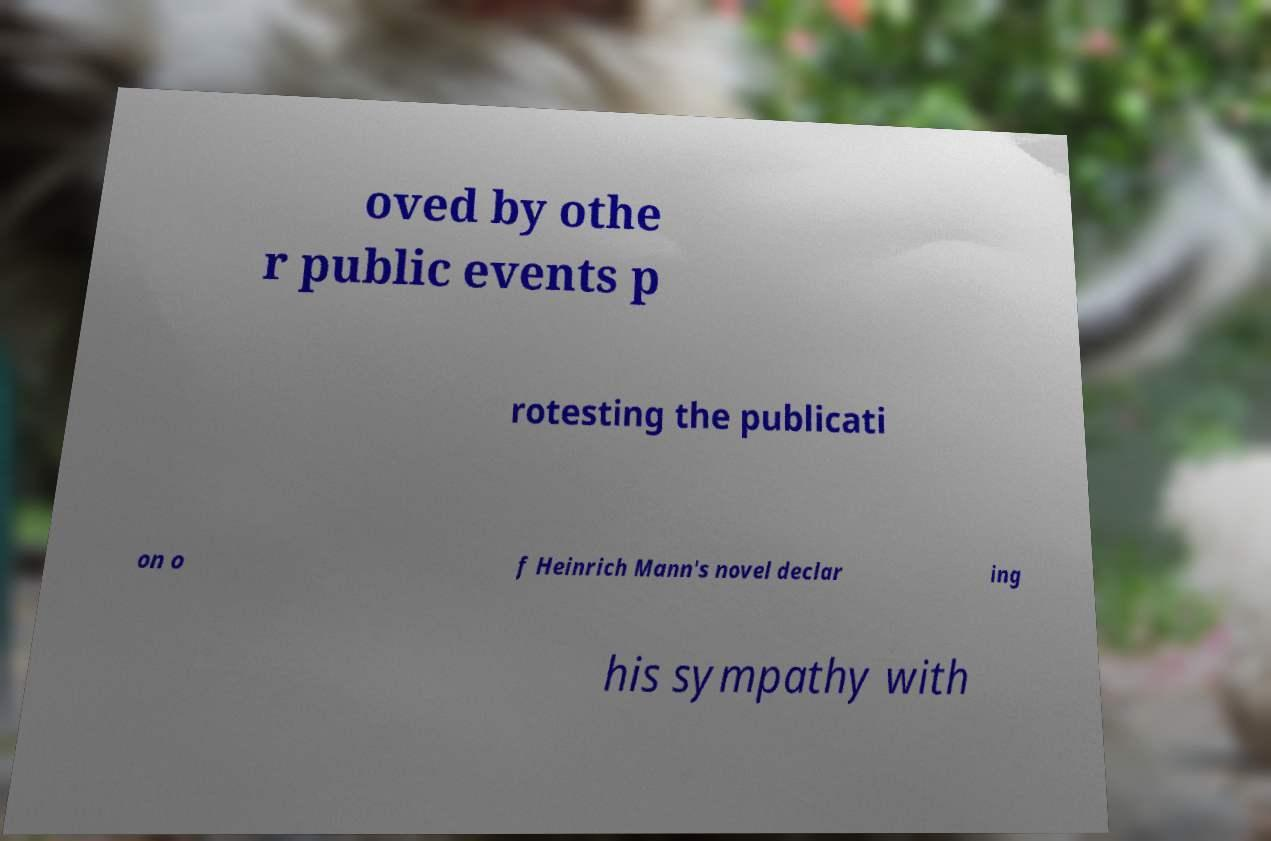Could you assist in decoding the text presented in this image and type it out clearly? oved by othe r public events p rotesting the publicati on o f Heinrich Mann's novel declar ing his sympathy with 